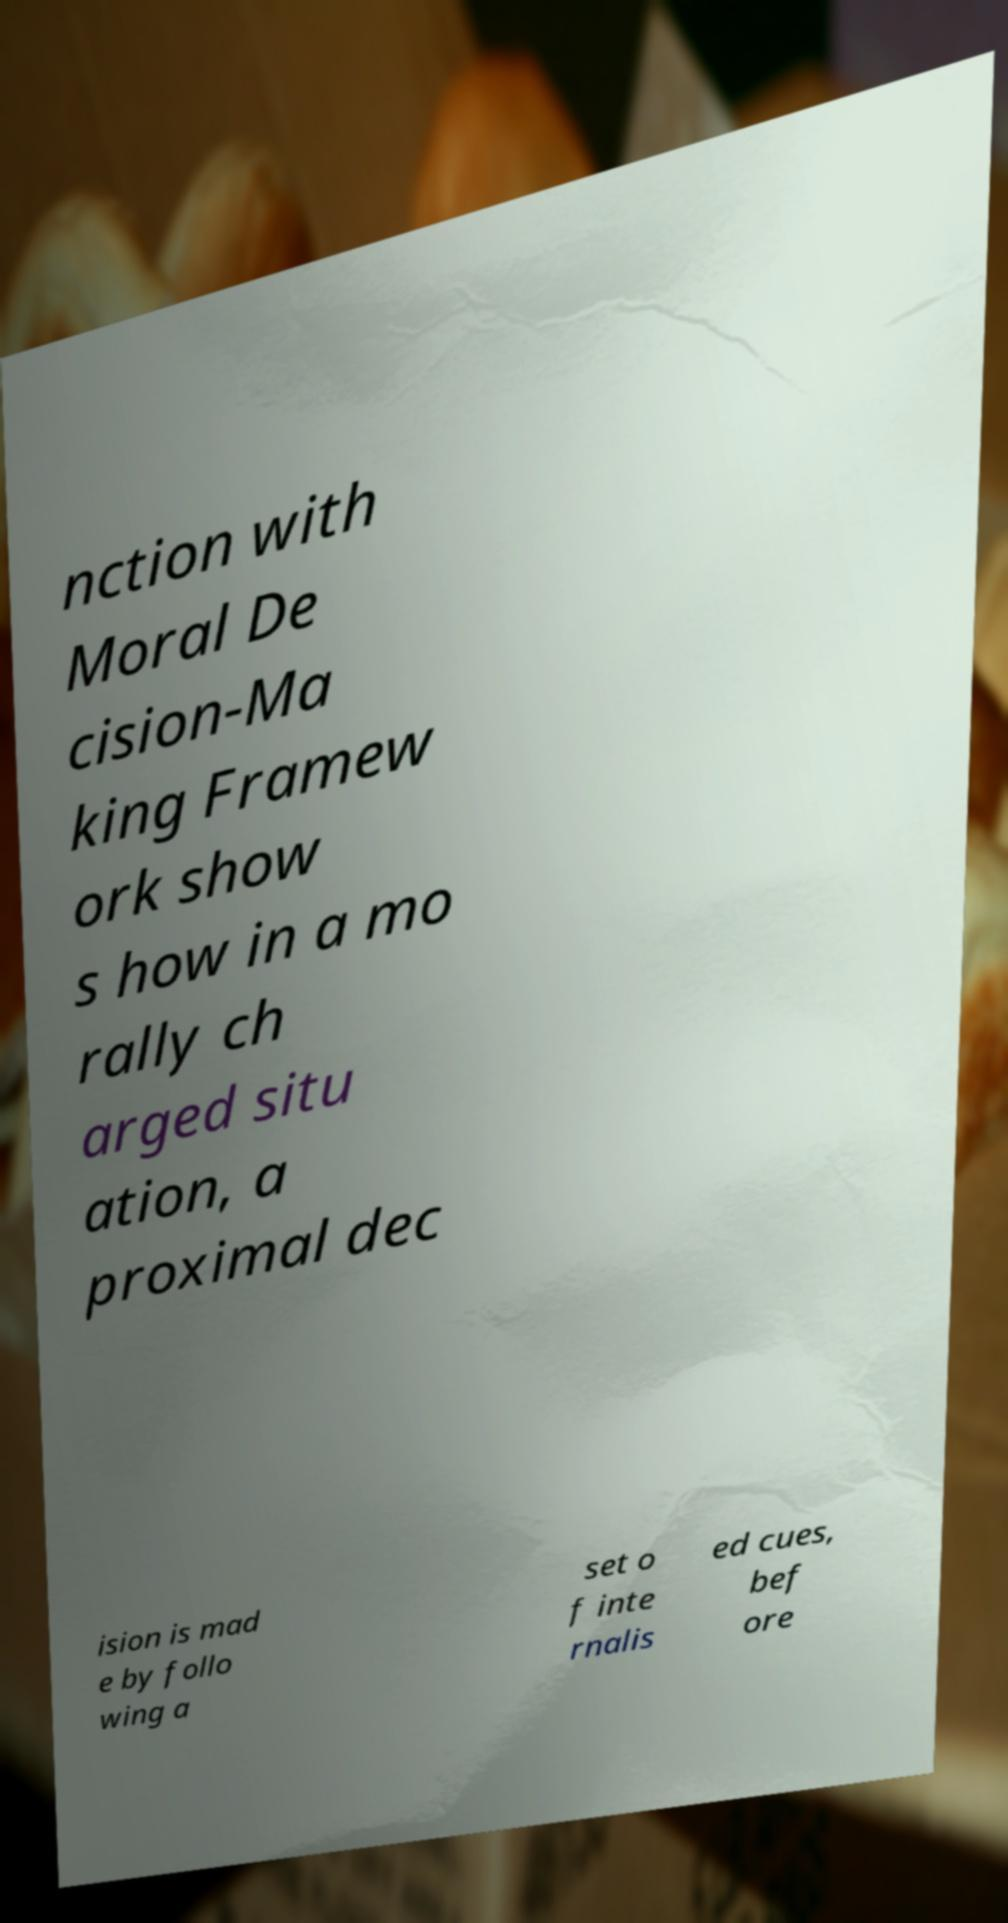Please read and relay the text visible in this image. What does it say? nction with Moral De cision-Ma king Framew ork show s how in a mo rally ch arged situ ation, a proximal dec ision is mad e by follo wing a set o f inte rnalis ed cues, bef ore 